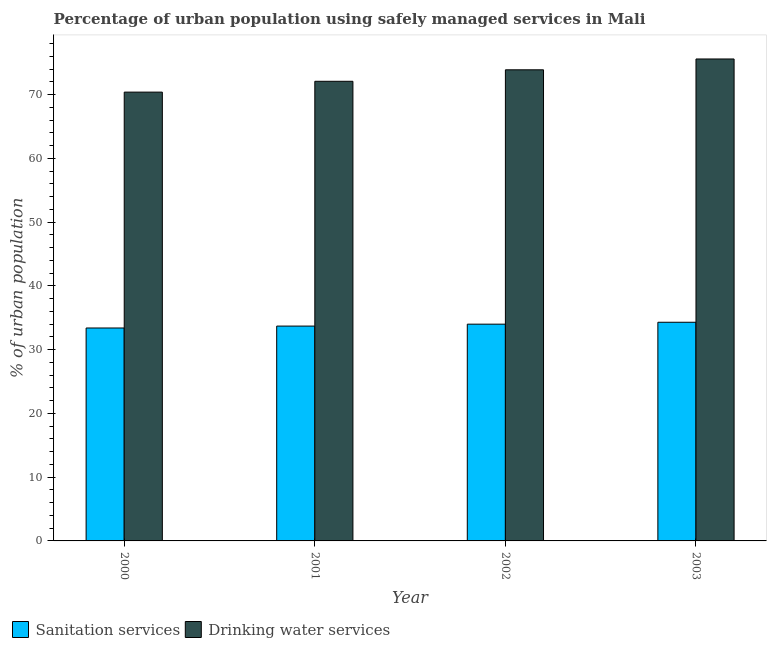How many groups of bars are there?
Offer a very short reply. 4. Are the number of bars per tick equal to the number of legend labels?
Your answer should be compact. Yes. How many bars are there on the 2nd tick from the left?
Ensure brevity in your answer.  2. How many bars are there on the 1st tick from the right?
Provide a short and direct response. 2. What is the label of the 4th group of bars from the left?
Offer a very short reply. 2003. What is the percentage of urban population who used sanitation services in 2001?
Make the answer very short. 33.7. Across all years, what is the maximum percentage of urban population who used drinking water services?
Keep it short and to the point. 75.6. Across all years, what is the minimum percentage of urban population who used sanitation services?
Your answer should be compact. 33.4. In which year was the percentage of urban population who used sanitation services maximum?
Provide a succinct answer. 2003. What is the total percentage of urban population who used drinking water services in the graph?
Your answer should be compact. 292. What is the difference between the percentage of urban population who used drinking water services in 2001 and that in 2002?
Your answer should be very brief. -1.8. What is the difference between the percentage of urban population who used sanitation services in 2000 and the percentage of urban population who used drinking water services in 2003?
Your answer should be very brief. -0.9. What is the average percentage of urban population who used sanitation services per year?
Offer a very short reply. 33.85. In how many years, is the percentage of urban population who used drinking water services greater than 74 %?
Your answer should be very brief. 1. What is the ratio of the percentage of urban population who used sanitation services in 2000 to that in 2001?
Give a very brief answer. 0.99. Is the percentage of urban population who used sanitation services in 2001 less than that in 2003?
Your answer should be very brief. Yes. What is the difference between the highest and the second highest percentage of urban population who used drinking water services?
Keep it short and to the point. 1.7. What is the difference between the highest and the lowest percentage of urban population who used drinking water services?
Offer a terse response. 5.2. In how many years, is the percentage of urban population who used drinking water services greater than the average percentage of urban population who used drinking water services taken over all years?
Your response must be concise. 2. What does the 1st bar from the left in 2003 represents?
Offer a very short reply. Sanitation services. What does the 2nd bar from the right in 2003 represents?
Offer a very short reply. Sanitation services. Are all the bars in the graph horizontal?
Ensure brevity in your answer.  No. What is the difference between two consecutive major ticks on the Y-axis?
Provide a succinct answer. 10. Are the values on the major ticks of Y-axis written in scientific E-notation?
Ensure brevity in your answer.  No. Does the graph contain grids?
Keep it short and to the point. No. Where does the legend appear in the graph?
Your answer should be very brief. Bottom left. How many legend labels are there?
Provide a short and direct response. 2. How are the legend labels stacked?
Your answer should be compact. Horizontal. What is the title of the graph?
Offer a terse response. Percentage of urban population using safely managed services in Mali. Does "Borrowers" appear as one of the legend labels in the graph?
Your response must be concise. No. What is the label or title of the Y-axis?
Your answer should be compact. % of urban population. What is the % of urban population of Sanitation services in 2000?
Ensure brevity in your answer.  33.4. What is the % of urban population in Drinking water services in 2000?
Ensure brevity in your answer.  70.4. What is the % of urban population of Sanitation services in 2001?
Offer a terse response. 33.7. What is the % of urban population in Drinking water services in 2001?
Ensure brevity in your answer.  72.1. What is the % of urban population in Drinking water services in 2002?
Your answer should be compact. 73.9. What is the % of urban population of Sanitation services in 2003?
Your answer should be compact. 34.3. What is the % of urban population of Drinking water services in 2003?
Keep it short and to the point. 75.6. Across all years, what is the maximum % of urban population of Sanitation services?
Give a very brief answer. 34.3. Across all years, what is the maximum % of urban population in Drinking water services?
Provide a short and direct response. 75.6. Across all years, what is the minimum % of urban population in Sanitation services?
Keep it short and to the point. 33.4. Across all years, what is the minimum % of urban population of Drinking water services?
Make the answer very short. 70.4. What is the total % of urban population of Sanitation services in the graph?
Provide a succinct answer. 135.4. What is the total % of urban population of Drinking water services in the graph?
Your answer should be compact. 292. What is the difference between the % of urban population in Sanitation services in 2000 and that in 2001?
Give a very brief answer. -0.3. What is the difference between the % of urban population of Drinking water services in 2000 and that in 2002?
Offer a very short reply. -3.5. What is the difference between the % of urban population in Sanitation services in 2000 and that in 2003?
Provide a succinct answer. -0.9. What is the difference between the % of urban population in Sanitation services in 2001 and that in 2002?
Provide a succinct answer. -0.3. What is the difference between the % of urban population in Drinking water services in 2001 and that in 2002?
Your answer should be very brief. -1.8. What is the difference between the % of urban population in Drinking water services in 2001 and that in 2003?
Your answer should be very brief. -3.5. What is the difference between the % of urban population of Drinking water services in 2002 and that in 2003?
Offer a very short reply. -1.7. What is the difference between the % of urban population in Sanitation services in 2000 and the % of urban population in Drinking water services in 2001?
Offer a terse response. -38.7. What is the difference between the % of urban population in Sanitation services in 2000 and the % of urban population in Drinking water services in 2002?
Provide a succinct answer. -40.5. What is the difference between the % of urban population in Sanitation services in 2000 and the % of urban population in Drinking water services in 2003?
Make the answer very short. -42.2. What is the difference between the % of urban population of Sanitation services in 2001 and the % of urban population of Drinking water services in 2002?
Provide a short and direct response. -40.2. What is the difference between the % of urban population in Sanitation services in 2001 and the % of urban population in Drinking water services in 2003?
Your response must be concise. -41.9. What is the difference between the % of urban population of Sanitation services in 2002 and the % of urban population of Drinking water services in 2003?
Provide a succinct answer. -41.6. What is the average % of urban population of Sanitation services per year?
Offer a terse response. 33.85. What is the average % of urban population in Drinking water services per year?
Your answer should be compact. 73. In the year 2000, what is the difference between the % of urban population in Sanitation services and % of urban population in Drinking water services?
Your answer should be very brief. -37. In the year 2001, what is the difference between the % of urban population of Sanitation services and % of urban population of Drinking water services?
Provide a short and direct response. -38.4. In the year 2002, what is the difference between the % of urban population in Sanitation services and % of urban population in Drinking water services?
Provide a succinct answer. -39.9. In the year 2003, what is the difference between the % of urban population of Sanitation services and % of urban population of Drinking water services?
Offer a terse response. -41.3. What is the ratio of the % of urban population of Drinking water services in 2000 to that in 2001?
Your response must be concise. 0.98. What is the ratio of the % of urban population of Sanitation services in 2000 to that in 2002?
Your response must be concise. 0.98. What is the ratio of the % of urban population of Drinking water services in 2000 to that in 2002?
Provide a succinct answer. 0.95. What is the ratio of the % of urban population of Sanitation services in 2000 to that in 2003?
Offer a very short reply. 0.97. What is the ratio of the % of urban population in Drinking water services in 2000 to that in 2003?
Give a very brief answer. 0.93. What is the ratio of the % of urban population of Drinking water services in 2001 to that in 2002?
Your response must be concise. 0.98. What is the ratio of the % of urban population in Sanitation services in 2001 to that in 2003?
Offer a terse response. 0.98. What is the ratio of the % of urban population in Drinking water services in 2001 to that in 2003?
Your answer should be compact. 0.95. What is the ratio of the % of urban population of Drinking water services in 2002 to that in 2003?
Your answer should be very brief. 0.98. What is the difference between the highest and the second highest % of urban population in Sanitation services?
Your response must be concise. 0.3. What is the difference between the highest and the second highest % of urban population of Drinking water services?
Provide a succinct answer. 1.7. What is the difference between the highest and the lowest % of urban population of Sanitation services?
Ensure brevity in your answer.  0.9. What is the difference between the highest and the lowest % of urban population in Drinking water services?
Your answer should be very brief. 5.2. 